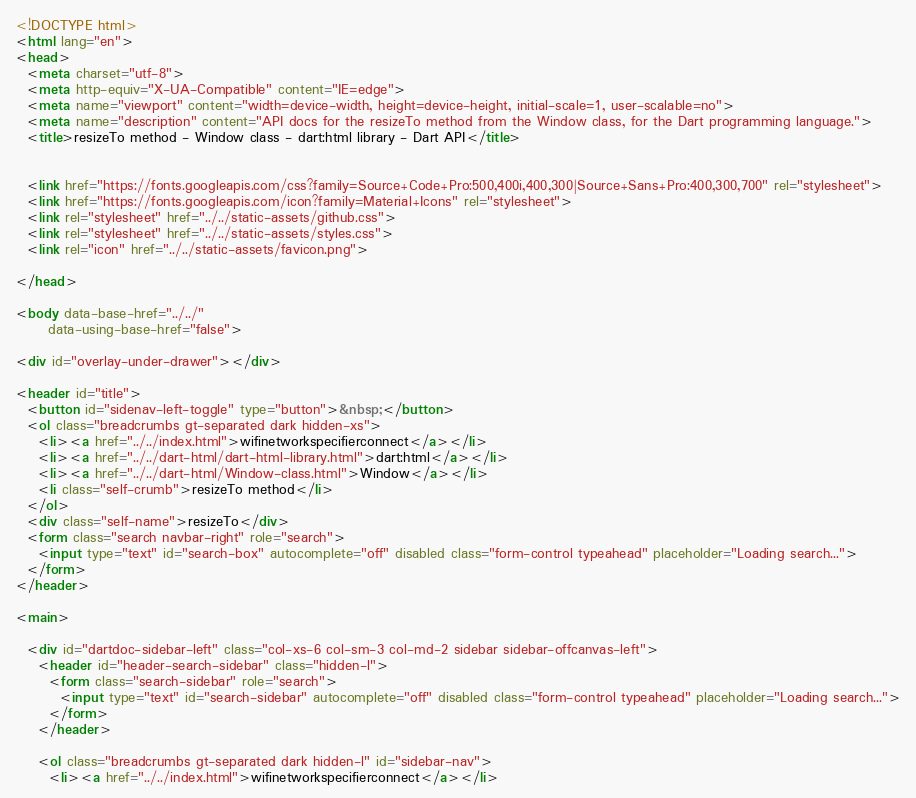<code> <loc_0><loc_0><loc_500><loc_500><_HTML_><!DOCTYPE html>
<html lang="en">
<head>
  <meta charset="utf-8">
  <meta http-equiv="X-UA-Compatible" content="IE=edge">
  <meta name="viewport" content="width=device-width, height=device-height, initial-scale=1, user-scalable=no">
  <meta name="description" content="API docs for the resizeTo method from the Window class, for the Dart programming language.">
  <title>resizeTo method - Window class - dart:html library - Dart API</title>

  
  <link href="https://fonts.googleapis.com/css?family=Source+Code+Pro:500,400i,400,300|Source+Sans+Pro:400,300,700" rel="stylesheet">
  <link href="https://fonts.googleapis.com/icon?family=Material+Icons" rel="stylesheet">
  <link rel="stylesheet" href="../../static-assets/github.css">
  <link rel="stylesheet" href="../../static-assets/styles.css">
  <link rel="icon" href="../../static-assets/favicon.png">

</head>

<body data-base-href="../../"
      data-using-base-href="false">

<div id="overlay-under-drawer"></div>

<header id="title">
  <button id="sidenav-left-toggle" type="button">&nbsp;</button>
  <ol class="breadcrumbs gt-separated dark hidden-xs">
    <li><a href="../../index.html">wifinetworkspecifierconnect</a></li>
    <li><a href="../../dart-html/dart-html-library.html">dart:html</a></li>
    <li><a href="../../dart-html/Window-class.html">Window</a></li>
    <li class="self-crumb">resizeTo method</li>
  </ol>
  <div class="self-name">resizeTo</div>
  <form class="search navbar-right" role="search">
    <input type="text" id="search-box" autocomplete="off" disabled class="form-control typeahead" placeholder="Loading search...">
  </form>
</header>

<main>

  <div id="dartdoc-sidebar-left" class="col-xs-6 col-sm-3 col-md-2 sidebar sidebar-offcanvas-left">
    <header id="header-search-sidebar" class="hidden-l">
      <form class="search-sidebar" role="search">
        <input type="text" id="search-sidebar" autocomplete="off" disabled class="form-control typeahead" placeholder="Loading search...">
      </form>
    </header>
    
    <ol class="breadcrumbs gt-separated dark hidden-l" id="sidebar-nav">
      <li><a href="../../index.html">wifinetworkspecifierconnect</a></li></code> 